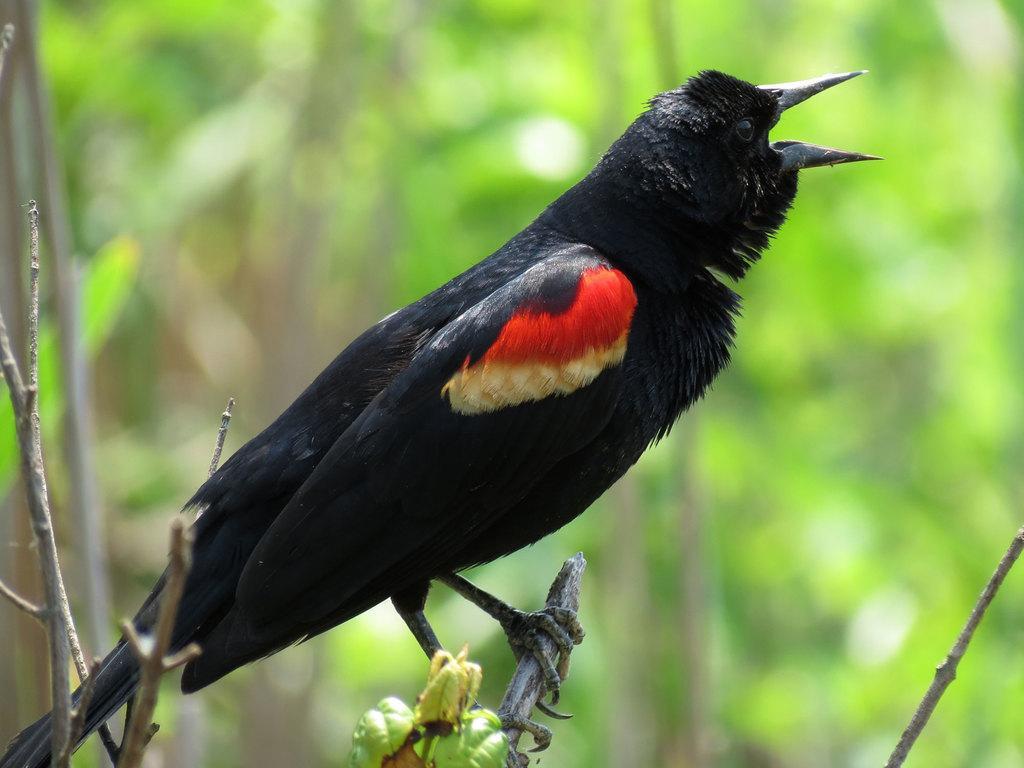Please provide a concise description of this image. In this picture we can see a bird on a branch and in the background we can see trees and it is blurry. 